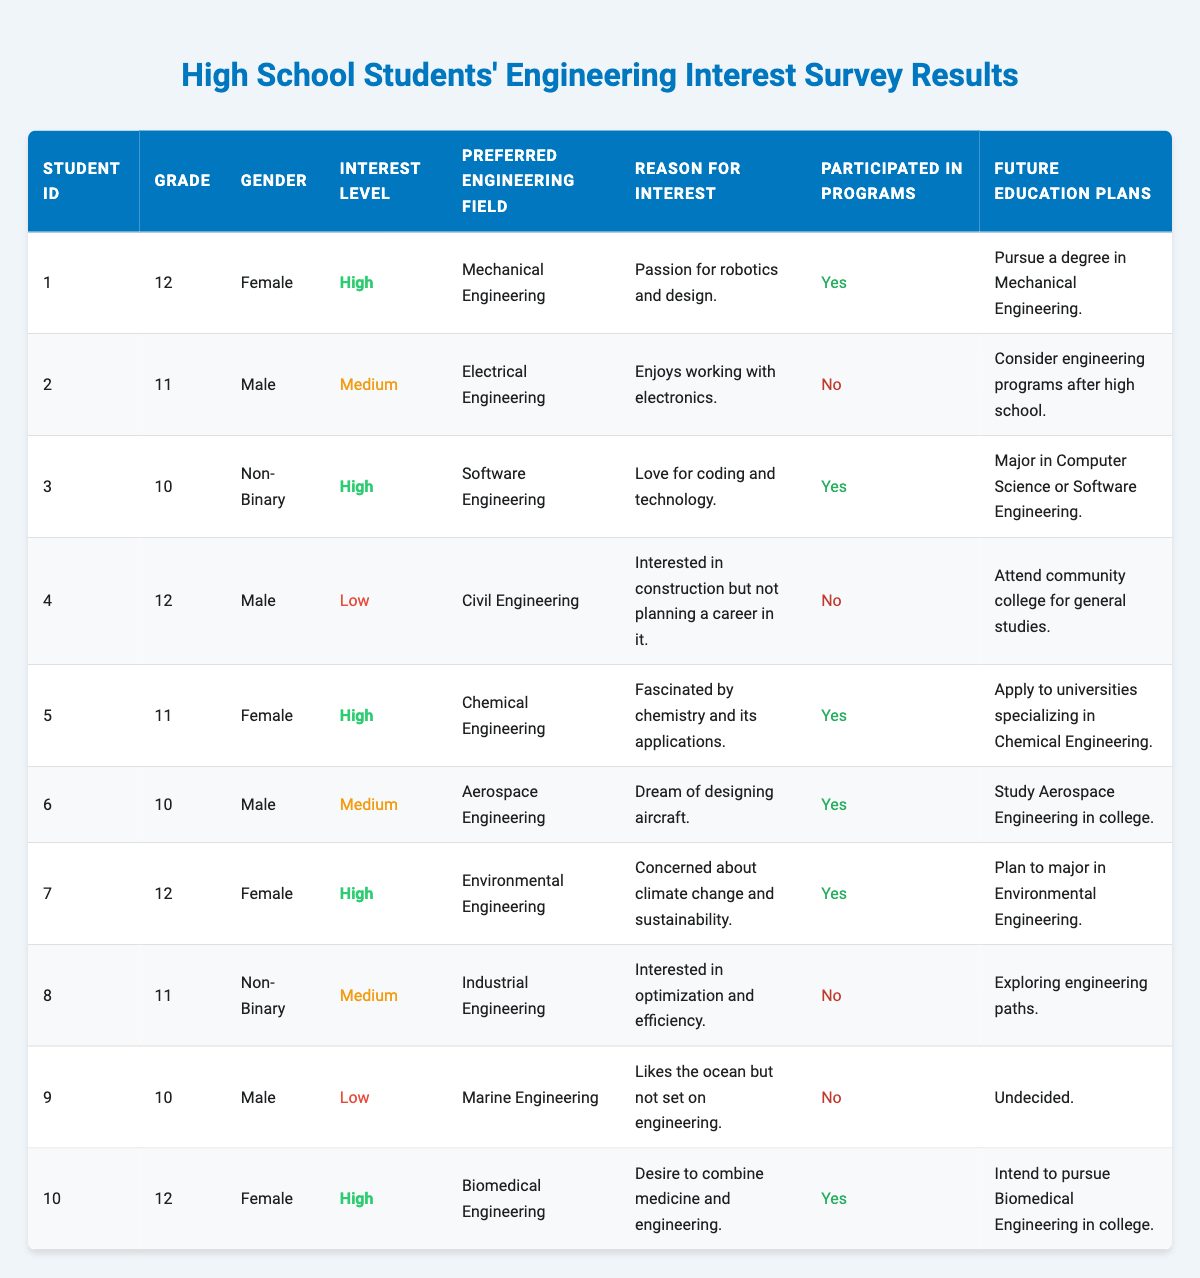What is the preferred engineering field for the student with the highest interest level? The student with the highest interest level (High) is ID 1 who prefers Mechanical Engineering, as shown in the interest level and preferred engineering field columns.
Answer: Mechanical Engineering How many students participated in engineering programs? Students who participated in engineering programs are those with a "Yes" in the participated in programs column. Counting these students, we find there are 5 who participated: IDs 1, 3, 5, 6, and 10.
Answer: 5 What percentage of students plan to major in engineering-related fields? Out of 10 students, 7 have specific plans related to engineering: IDs 1, 3, 5, 7, 6, 10. To find the percentage, we calculate (7/10)*100 which gives us 70%.
Answer: 70% Who is the male student with the lowest interest level? The male student with the lowest interest level is ID 4, as seen in the interest level column where he is marked as Low. Looking at his gender, we confirm he is Male.
Answer: Student ID 4 What is the average grade of students who preferred Chemical Engineering? Only one student (ID 5) preferred Chemical Engineering and he is in grade 11. Therefore, the average is simply his grade, which is 11.
Answer: 11 Did any non-binary students participate in engineering programs? The non-binary students in the table are IDs 3 and 8. ID 3 participated (Yes) and ID 8 did not (No). Since at least one of them participated, the answer is Yes.
Answer: Yes What is the most common reason for students' interest in engineering? The reasons listed are quite varied, so we look for the most common themes. "Passion for robotics and design" appears once, "Enjoys working with electronics" once, "Love for coding and technology" once, "Fascinated by chemistry and its applications" once, "Dream of designing aircraft" once, "Concerned about climate change" once, and "Desire to combine medicine and engineering" appears once. No single theme repeats, so there isn't a most common reason.
Answer: No common reason How many students are interested in Civil Engineering and what is their grade? There is only one student interested in Civil Engineering, who is ID 4, and he is in grade 12. Hence the answer is one student and his grade is 12.
Answer: 1 student, Grade 12 What is the ratio of students interested in Environmental Engineering to those with a low interest level? There is 1 student interested in Environmental Engineering (ID 7) and there are 3 students with low interest (IDs 4, 9). The ratio is 1 to 3.
Answer: 1:3 